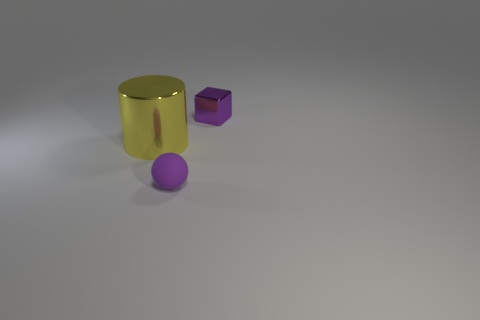Add 3 large red shiny cylinders. How many objects exist? 6 Subtract all cylinders. How many objects are left? 2 Add 1 large metallic objects. How many large metallic objects are left? 2 Add 1 purple matte objects. How many purple matte objects exist? 2 Subtract 0 purple cylinders. How many objects are left? 3 Subtract all tiny yellow matte spheres. Subtract all small rubber balls. How many objects are left? 2 